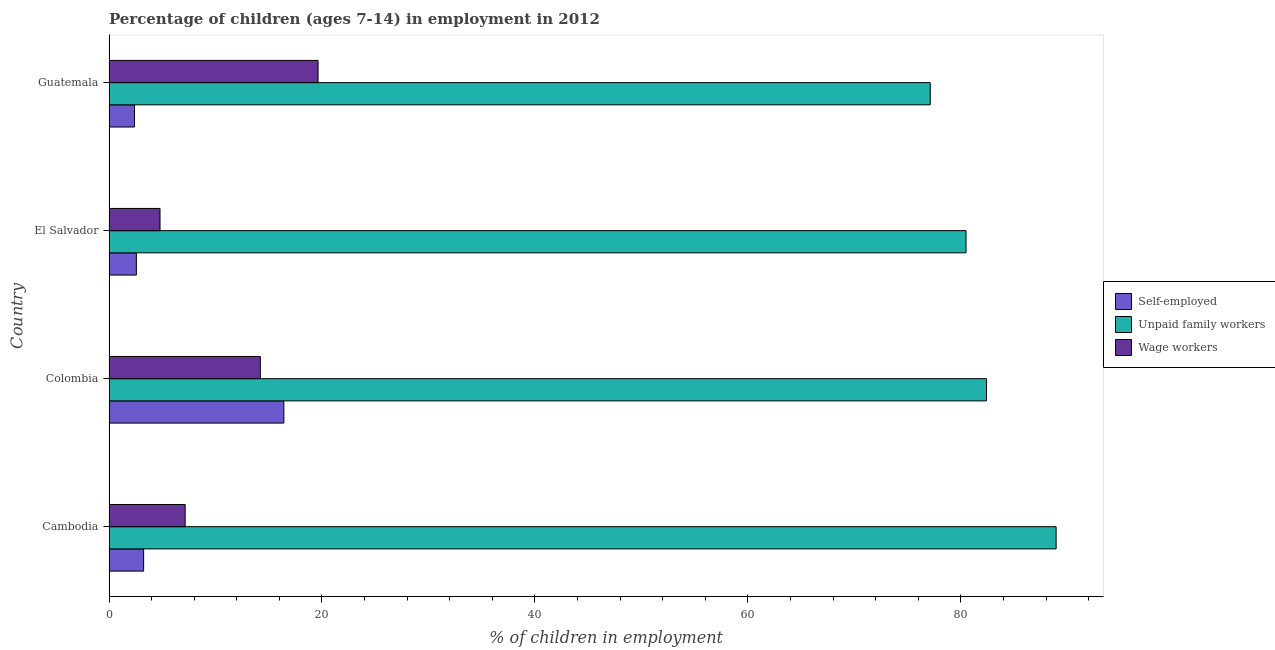How many different coloured bars are there?
Provide a short and direct response. 3. Are the number of bars on each tick of the Y-axis equal?
Keep it short and to the point. Yes. How many bars are there on the 2nd tick from the top?
Make the answer very short. 3. What is the percentage of children employed as wage workers in Cambodia?
Your response must be concise. 7.15. Across all countries, what is the maximum percentage of children employed as wage workers?
Your answer should be very brief. 19.63. Across all countries, what is the minimum percentage of self employed children?
Offer a very short reply. 2.39. In which country was the percentage of children employed as wage workers maximum?
Offer a terse response. Guatemala. In which country was the percentage of children employed as wage workers minimum?
Give a very brief answer. El Salvador. What is the total percentage of children employed as wage workers in the graph?
Give a very brief answer. 45.78. What is the difference between the percentage of children employed as wage workers in Colombia and that in Guatemala?
Offer a terse response. -5.42. What is the difference between the percentage of children employed as unpaid family workers in Guatemala and the percentage of children employed as wage workers in Colombia?
Give a very brief answer. 62.91. What is the average percentage of children employed as wage workers per country?
Your answer should be compact. 11.45. What is the difference between the percentage of children employed as unpaid family workers and percentage of children employed as wage workers in Colombia?
Make the answer very short. 68.19. In how many countries, is the percentage of children employed as wage workers greater than 8 %?
Your answer should be very brief. 2. What is the ratio of the percentage of self employed children in Cambodia to that in El Salvador?
Offer a terse response. 1.26. Is the difference between the percentage of children employed as wage workers in Cambodia and Colombia greater than the difference between the percentage of self employed children in Cambodia and Colombia?
Provide a succinct answer. Yes. What is the difference between the highest and the second highest percentage of children employed as wage workers?
Provide a short and direct response. 5.42. What is the difference between the highest and the lowest percentage of children employed as wage workers?
Offer a very short reply. 14.84. Is the sum of the percentage of children employed as wage workers in Cambodia and El Salvador greater than the maximum percentage of self employed children across all countries?
Your answer should be compact. No. What does the 2nd bar from the top in Cambodia represents?
Give a very brief answer. Unpaid family workers. What does the 1st bar from the bottom in Cambodia represents?
Offer a very short reply. Self-employed. Is it the case that in every country, the sum of the percentage of self employed children and percentage of children employed as unpaid family workers is greater than the percentage of children employed as wage workers?
Keep it short and to the point. Yes. How many bars are there?
Provide a short and direct response. 12. Are all the bars in the graph horizontal?
Your answer should be compact. Yes. Are the values on the major ticks of X-axis written in scientific E-notation?
Ensure brevity in your answer.  No. Does the graph contain any zero values?
Your answer should be very brief. No. How are the legend labels stacked?
Your answer should be very brief. Vertical. What is the title of the graph?
Keep it short and to the point. Percentage of children (ages 7-14) in employment in 2012. Does "Agricultural Nitrous Oxide" appear as one of the legend labels in the graph?
Give a very brief answer. No. What is the label or title of the X-axis?
Your response must be concise. % of children in employment. What is the label or title of the Y-axis?
Provide a short and direct response. Country. What is the % of children in employment of Self-employed in Cambodia?
Your answer should be very brief. 3.25. What is the % of children in employment of Unpaid family workers in Cambodia?
Your answer should be very brief. 88.94. What is the % of children in employment of Wage workers in Cambodia?
Your response must be concise. 7.15. What is the % of children in employment of Self-employed in Colombia?
Keep it short and to the point. 16.42. What is the % of children in employment of Unpaid family workers in Colombia?
Provide a succinct answer. 82.4. What is the % of children in employment of Wage workers in Colombia?
Your answer should be compact. 14.21. What is the % of children in employment in Self-employed in El Salvador?
Offer a very short reply. 2.57. What is the % of children in employment of Unpaid family workers in El Salvador?
Offer a terse response. 80.48. What is the % of children in employment in Wage workers in El Salvador?
Keep it short and to the point. 4.79. What is the % of children in employment in Self-employed in Guatemala?
Your answer should be very brief. 2.39. What is the % of children in employment in Unpaid family workers in Guatemala?
Your answer should be very brief. 77.12. What is the % of children in employment of Wage workers in Guatemala?
Provide a short and direct response. 19.63. Across all countries, what is the maximum % of children in employment of Self-employed?
Give a very brief answer. 16.42. Across all countries, what is the maximum % of children in employment in Unpaid family workers?
Provide a short and direct response. 88.94. Across all countries, what is the maximum % of children in employment of Wage workers?
Your response must be concise. 19.63. Across all countries, what is the minimum % of children in employment in Self-employed?
Give a very brief answer. 2.39. Across all countries, what is the minimum % of children in employment of Unpaid family workers?
Give a very brief answer. 77.12. Across all countries, what is the minimum % of children in employment of Wage workers?
Make the answer very short. 4.79. What is the total % of children in employment in Self-employed in the graph?
Give a very brief answer. 24.63. What is the total % of children in employment of Unpaid family workers in the graph?
Your answer should be compact. 328.94. What is the total % of children in employment in Wage workers in the graph?
Give a very brief answer. 45.78. What is the difference between the % of children in employment in Self-employed in Cambodia and that in Colombia?
Offer a very short reply. -13.17. What is the difference between the % of children in employment in Unpaid family workers in Cambodia and that in Colombia?
Make the answer very short. 6.54. What is the difference between the % of children in employment in Wage workers in Cambodia and that in Colombia?
Your answer should be very brief. -7.06. What is the difference between the % of children in employment in Self-employed in Cambodia and that in El Salvador?
Offer a terse response. 0.68. What is the difference between the % of children in employment of Unpaid family workers in Cambodia and that in El Salvador?
Provide a short and direct response. 8.46. What is the difference between the % of children in employment in Wage workers in Cambodia and that in El Salvador?
Keep it short and to the point. 2.36. What is the difference between the % of children in employment in Self-employed in Cambodia and that in Guatemala?
Offer a very short reply. 0.86. What is the difference between the % of children in employment in Unpaid family workers in Cambodia and that in Guatemala?
Provide a short and direct response. 11.82. What is the difference between the % of children in employment in Wage workers in Cambodia and that in Guatemala?
Your answer should be compact. -12.48. What is the difference between the % of children in employment of Self-employed in Colombia and that in El Salvador?
Provide a succinct answer. 13.85. What is the difference between the % of children in employment of Unpaid family workers in Colombia and that in El Salvador?
Keep it short and to the point. 1.92. What is the difference between the % of children in employment of Wage workers in Colombia and that in El Salvador?
Provide a short and direct response. 9.42. What is the difference between the % of children in employment of Self-employed in Colombia and that in Guatemala?
Make the answer very short. 14.03. What is the difference between the % of children in employment in Unpaid family workers in Colombia and that in Guatemala?
Your answer should be very brief. 5.28. What is the difference between the % of children in employment in Wage workers in Colombia and that in Guatemala?
Give a very brief answer. -5.42. What is the difference between the % of children in employment of Self-employed in El Salvador and that in Guatemala?
Provide a succinct answer. 0.18. What is the difference between the % of children in employment in Unpaid family workers in El Salvador and that in Guatemala?
Ensure brevity in your answer.  3.36. What is the difference between the % of children in employment in Wage workers in El Salvador and that in Guatemala?
Give a very brief answer. -14.84. What is the difference between the % of children in employment in Self-employed in Cambodia and the % of children in employment in Unpaid family workers in Colombia?
Give a very brief answer. -79.15. What is the difference between the % of children in employment in Self-employed in Cambodia and the % of children in employment in Wage workers in Colombia?
Make the answer very short. -10.96. What is the difference between the % of children in employment in Unpaid family workers in Cambodia and the % of children in employment in Wage workers in Colombia?
Your answer should be compact. 74.73. What is the difference between the % of children in employment in Self-employed in Cambodia and the % of children in employment in Unpaid family workers in El Salvador?
Make the answer very short. -77.23. What is the difference between the % of children in employment of Self-employed in Cambodia and the % of children in employment of Wage workers in El Salvador?
Ensure brevity in your answer.  -1.54. What is the difference between the % of children in employment in Unpaid family workers in Cambodia and the % of children in employment in Wage workers in El Salvador?
Give a very brief answer. 84.15. What is the difference between the % of children in employment in Self-employed in Cambodia and the % of children in employment in Unpaid family workers in Guatemala?
Offer a very short reply. -73.87. What is the difference between the % of children in employment in Self-employed in Cambodia and the % of children in employment in Wage workers in Guatemala?
Provide a short and direct response. -16.38. What is the difference between the % of children in employment in Unpaid family workers in Cambodia and the % of children in employment in Wage workers in Guatemala?
Provide a succinct answer. 69.31. What is the difference between the % of children in employment of Self-employed in Colombia and the % of children in employment of Unpaid family workers in El Salvador?
Provide a succinct answer. -64.06. What is the difference between the % of children in employment in Self-employed in Colombia and the % of children in employment in Wage workers in El Salvador?
Make the answer very short. 11.63. What is the difference between the % of children in employment in Unpaid family workers in Colombia and the % of children in employment in Wage workers in El Salvador?
Offer a very short reply. 77.61. What is the difference between the % of children in employment in Self-employed in Colombia and the % of children in employment in Unpaid family workers in Guatemala?
Your answer should be very brief. -60.7. What is the difference between the % of children in employment in Self-employed in Colombia and the % of children in employment in Wage workers in Guatemala?
Your response must be concise. -3.21. What is the difference between the % of children in employment of Unpaid family workers in Colombia and the % of children in employment of Wage workers in Guatemala?
Make the answer very short. 62.77. What is the difference between the % of children in employment in Self-employed in El Salvador and the % of children in employment in Unpaid family workers in Guatemala?
Your answer should be compact. -74.55. What is the difference between the % of children in employment in Self-employed in El Salvador and the % of children in employment in Wage workers in Guatemala?
Your answer should be compact. -17.06. What is the difference between the % of children in employment in Unpaid family workers in El Salvador and the % of children in employment in Wage workers in Guatemala?
Ensure brevity in your answer.  60.85. What is the average % of children in employment in Self-employed per country?
Make the answer very short. 6.16. What is the average % of children in employment in Unpaid family workers per country?
Ensure brevity in your answer.  82.23. What is the average % of children in employment of Wage workers per country?
Give a very brief answer. 11.45. What is the difference between the % of children in employment of Self-employed and % of children in employment of Unpaid family workers in Cambodia?
Your response must be concise. -85.69. What is the difference between the % of children in employment of Unpaid family workers and % of children in employment of Wage workers in Cambodia?
Provide a succinct answer. 81.79. What is the difference between the % of children in employment in Self-employed and % of children in employment in Unpaid family workers in Colombia?
Make the answer very short. -65.98. What is the difference between the % of children in employment in Self-employed and % of children in employment in Wage workers in Colombia?
Provide a succinct answer. 2.21. What is the difference between the % of children in employment in Unpaid family workers and % of children in employment in Wage workers in Colombia?
Your answer should be very brief. 68.19. What is the difference between the % of children in employment in Self-employed and % of children in employment in Unpaid family workers in El Salvador?
Ensure brevity in your answer.  -77.91. What is the difference between the % of children in employment in Self-employed and % of children in employment in Wage workers in El Salvador?
Your answer should be compact. -2.22. What is the difference between the % of children in employment in Unpaid family workers and % of children in employment in Wage workers in El Salvador?
Your answer should be compact. 75.69. What is the difference between the % of children in employment in Self-employed and % of children in employment in Unpaid family workers in Guatemala?
Provide a succinct answer. -74.73. What is the difference between the % of children in employment of Self-employed and % of children in employment of Wage workers in Guatemala?
Give a very brief answer. -17.24. What is the difference between the % of children in employment in Unpaid family workers and % of children in employment in Wage workers in Guatemala?
Keep it short and to the point. 57.49. What is the ratio of the % of children in employment of Self-employed in Cambodia to that in Colombia?
Provide a short and direct response. 0.2. What is the ratio of the % of children in employment in Unpaid family workers in Cambodia to that in Colombia?
Offer a very short reply. 1.08. What is the ratio of the % of children in employment in Wage workers in Cambodia to that in Colombia?
Your response must be concise. 0.5. What is the ratio of the % of children in employment in Self-employed in Cambodia to that in El Salvador?
Your answer should be very brief. 1.26. What is the ratio of the % of children in employment in Unpaid family workers in Cambodia to that in El Salvador?
Ensure brevity in your answer.  1.11. What is the ratio of the % of children in employment of Wage workers in Cambodia to that in El Salvador?
Your answer should be very brief. 1.49. What is the ratio of the % of children in employment in Self-employed in Cambodia to that in Guatemala?
Your answer should be compact. 1.36. What is the ratio of the % of children in employment of Unpaid family workers in Cambodia to that in Guatemala?
Your answer should be very brief. 1.15. What is the ratio of the % of children in employment of Wage workers in Cambodia to that in Guatemala?
Give a very brief answer. 0.36. What is the ratio of the % of children in employment in Self-employed in Colombia to that in El Salvador?
Provide a succinct answer. 6.39. What is the ratio of the % of children in employment in Unpaid family workers in Colombia to that in El Salvador?
Provide a short and direct response. 1.02. What is the ratio of the % of children in employment in Wage workers in Colombia to that in El Salvador?
Ensure brevity in your answer.  2.97. What is the ratio of the % of children in employment in Self-employed in Colombia to that in Guatemala?
Your response must be concise. 6.87. What is the ratio of the % of children in employment of Unpaid family workers in Colombia to that in Guatemala?
Give a very brief answer. 1.07. What is the ratio of the % of children in employment in Wage workers in Colombia to that in Guatemala?
Your response must be concise. 0.72. What is the ratio of the % of children in employment of Self-employed in El Salvador to that in Guatemala?
Your response must be concise. 1.08. What is the ratio of the % of children in employment in Unpaid family workers in El Salvador to that in Guatemala?
Ensure brevity in your answer.  1.04. What is the ratio of the % of children in employment in Wage workers in El Salvador to that in Guatemala?
Provide a short and direct response. 0.24. What is the difference between the highest and the second highest % of children in employment in Self-employed?
Provide a succinct answer. 13.17. What is the difference between the highest and the second highest % of children in employment of Unpaid family workers?
Offer a terse response. 6.54. What is the difference between the highest and the second highest % of children in employment in Wage workers?
Your answer should be very brief. 5.42. What is the difference between the highest and the lowest % of children in employment of Self-employed?
Make the answer very short. 14.03. What is the difference between the highest and the lowest % of children in employment of Unpaid family workers?
Provide a succinct answer. 11.82. What is the difference between the highest and the lowest % of children in employment in Wage workers?
Your answer should be very brief. 14.84. 